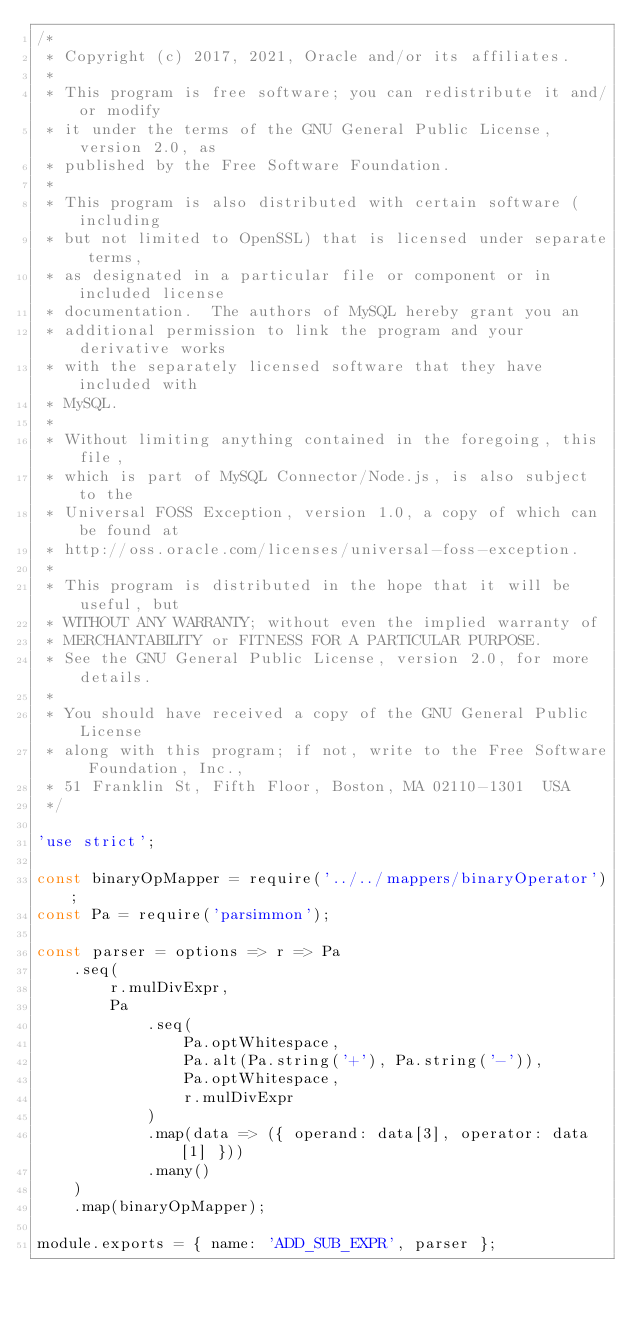<code> <loc_0><loc_0><loc_500><loc_500><_JavaScript_>/*
 * Copyright (c) 2017, 2021, Oracle and/or its affiliates.
 *
 * This program is free software; you can redistribute it and/or modify
 * it under the terms of the GNU General Public License, version 2.0, as
 * published by the Free Software Foundation.
 *
 * This program is also distributed with certain software (including
 * but not limited to OpenSSL) that is licensed under separate terms,
 * as designated in a particular file or component or in included license
 * documentation.  The authors of MySQL hereby grant you an
 * additional permission to link the program and your derivative works
 * with the separately licensed software that they have included with
 * MySQL.
 *
 * Without limiting anything contained in the foregoing, this file,
 * which is part of MySQL Connector/Node.js, is also subject to the
 * Universal FOSS Exception, version 1.0, a copy of which can be found at
 * http://oss.oracle.com/licenses/universal-foss-exception.
 *
 * This program is distributed in the hope that it will be useful, but
 * WITHOUT ANY WARRANTY; without even the implied warranty of
 * MERCHANTABILITY or FITNESS FOR A PARTICULAR PURPOSE.
 * See the GNU General Public License, version 2.0, for more details.
 *
 * You should have received a copy of the GNU General Public License
 * along with this program; if not, write to the Free Software Foundation, Inc.,
 * 51 Franklin St, Fifth Floor, Boston, MA 02110-1301  USA
 */

'use strict';

const binaryOpMapper = require('../../mappers/binaryOperator');
const Pa = require('parsimmon');

const parser = options => r => Pa
    .seq(
        r.mulDivExpr,
        Pa
            .seq(
                Pa.optWhitespace,
                Pa.alt(Pa.string('+'), Pa.string('-')),
                Pa.optWhitespace,
                r.mulDivExpr
            )
            .map(data => ({ operand: data[3], operator: data[1] }))
            .many()
    )
    .map(binaryOpMapper);

module.exports = { name: 'ADD_SUB_EXPR', parser };
</code> 